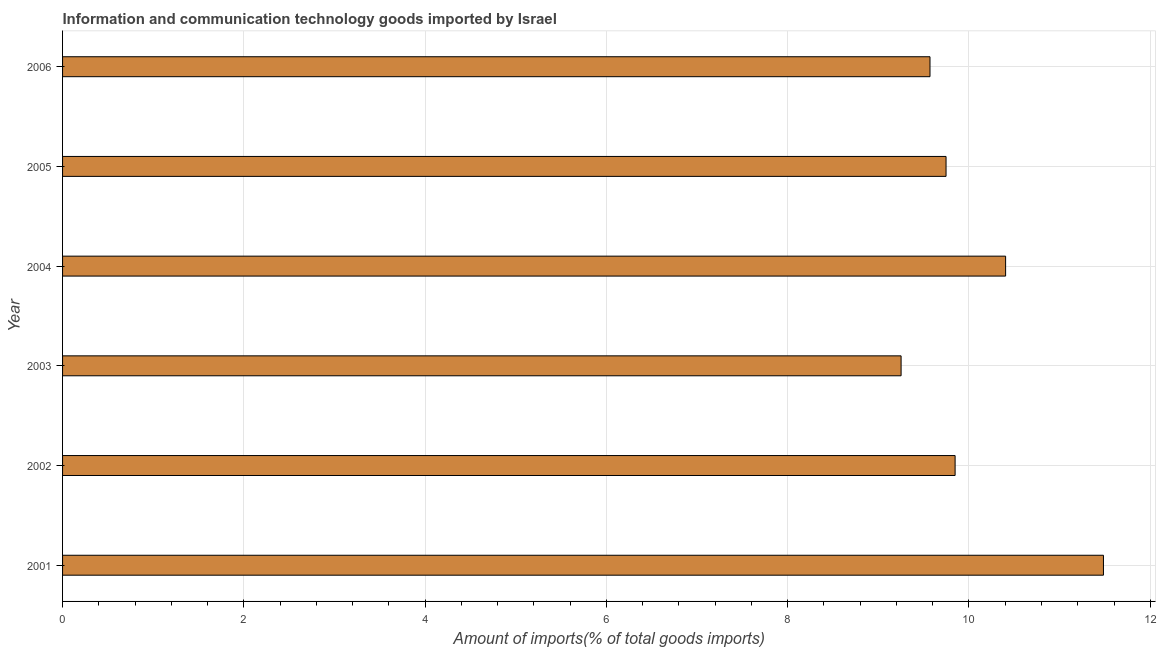Does the graph contain any zero values?
Give a very brief answer. No. What is the title of the graph?
Keep it short and to the point. Information and communication technology goods imported by Israel. What is the label or title of the X-axis?
Offer a terse response. Amount of imports(% of total goods imports). What is the label or title of the Y-axis?
Provide a short and direct response. Year. What is the amount of ict goods imports in 2004?
Offer a very short reply. 10.4. Across all years, what is the maximum amount of ict goods imports?
Provide a succinct answer. 11.48. Across all years, what is the minimum amount of ict goods imports?
Make the answer very short. 9.25. What is the sum of the amount of ict goods imports?
Keep it short and to the point. 60.3. What is the difference between the amount of ict goods imports in 2002 and 2003?
Provide a short and direct response. 0.6. What is the average amount of ict goods imports per year?
Keep it short and to the point. 10.05. What is the median amount of ict goods imports?
Provide a short and direct response. 9.8. In how many years, is the amount of ict goods imports greater than 3.2 %?
Offer a terse response. 6. Do a majority of the years between 2003 and 2004 (inclusive) have amount of ict goods imports greater than 10.4 %?
Make the answer very short. No. What is the ratio of the amount of ict goods imports in 2003 to that in 2004?
Provide a short and direct response. 0.89. What is the difference between the highest and the second highest amount of ict goods imports?
Offer a very short reply. 1.08. Is the sum of the amount of ict goods imports in 2001 and 2002 greater than the maximum amount of ict goods imports across all years?
Provide a succinct answer. Yes. What is the difference between the highest and the lowest amount of ict goods imports?
Provide a succinct answer. 2.23. In how many years, is the amount of ict goods imports greater than the average amount of ict goods imports taken over all years?
Provide a short and direct response. 2. How many bars are there?
Provide a succinct answer. 6. Are all the bars in the graph horizontal?
Your answer should be compact. Yes. What is the Amount of imports(% of total goods imports) in 2001?
Ensure brevity in your answer.  11.48. What is the Amount of imports(% of total goods imports) of 2002?
Offer a very short reply. 9.85. What is the Amount of imports(% of total goods imports) of 2003?
Provide a succinct answer. 9.25. What is the Amount of imports(% of total goods imports) of 2004?
Your answer should be compact. 10.4. What is the Amount of imports(% of total goods imports) in 2005?
Provide a succinct answer. 9.75. What is the Amount of imports(% of total goods imports) in 2006?
Give a very brief answer. 9.57. What is the difference between the Amount of imports(% of total goods imports) in 2001 and 2002?
Your answer should be compact. 1.64. What is the difference between the Amount of imports(% of total goods imports) in 2001 and 2003?
Give a very brief answer. 2.23. What is the difference between the Amount of imports(% of total goods imports) in 2001 and 2004?
Your answer should be compact. 1.08. What is the difference between the Amount of imports(% of total goods imports) in 2001 and 2005?
Your answer should be compact. 1.74. What is the difference between the Amount of imports(% of total goods imports) in 2001 and 2006?
Your answer should be compact. 1.91. What is the difference between the Amount of imports(% of total goods imports) in 2002 and 2003?
Make the answer very short. 0.6. What is the difference between the Amount of imports(% of total goods imports) in 2002 and 2004?
Your answer should be compact. -0.56. What is the difference between the Amount of imports(% of total goods imports) in 2002 and 2005?
Your response must be concise. 0.1. What is the difference between the Amount of imports(% of total goods imports) in 2002 and 2006?
Keep it short and to the point. 0.28. What is the difference between the Amount of imports(% of total goods imports) in 2003 and 2004?
Your answer should be compact. -1.15. What is the difference between the Amount of imports(% of total goods imports) in 2003 and 2005?
Your answer should be compact. -0.5. What is the difference between the Amount of imports(% of total goods imports) in 2003 and 2006?
Offer a very short reply. -0.32. What is the difference between the Amount of imports(% of total goods imports) in 2004 and 2005?
Give a very brief answer. 0.66. What is the difference between the Amount of imports(% of total goods imports) in 2004 and 2006?
Provide a succinct answer. 0.83. What is the difference between the Amount of imports(% of total goods imports) in 2005 and 2006?
Your response must be concise. 0.18. What is the ratio of the Amount of imports(% of total goods imports) in 2001 to that in 2002?
Keep it short and to the point. 1.17. What is the ratio of the Amount of imports(% of total goods imports) in 2001 to that in 2003?
Keep it short and to the point. 1.24. What is the ratio of the Amount of imports(% of total goods imports) in 2001 to that in 2004?
Provide a succinct answer. 1.1. What is the ratio of the Amount of imports(% of total goods imports) in 2001 to that in 2005?
Ensure brevity in your answer.  1.18. What is the ratio of the Amount of imports(% of total goods imports) in 2002 to that in 2003?
Provide a succinct answer. 1.06. What is the ratio of the Amount of imports(% of total goods imports) in 2002 to that in 2004?
Provide a succinct answer. 0.95. What is the ratio of the Amount of imports(% of total goods imports) in 2002 to that in 2005?
Keep it short and to the point. 1.01. What is the ratio of the Amount of imports(% of total goods imports) in 2002 to that in 2006?
Offer a terse response. 1.03. What is the ratio of the Amount of imports(% of total goods imports) in 2003 to that in 2004?
Offer a terse response. 0.89. What is the ratio of the Amount of imports(% of total goods imports) in 2003 to that in 2005?
Give a very brief answer. 0.95. What is the ratio of the Amount of imports(% of total goods imports) in 2004 to that in 2005?
Offer a very short reply. 1.07. What is the ratio of the Amount of imports(% of total goods imports) in 2004 to that in 2006?
Offer a very short reply. 1.09. 